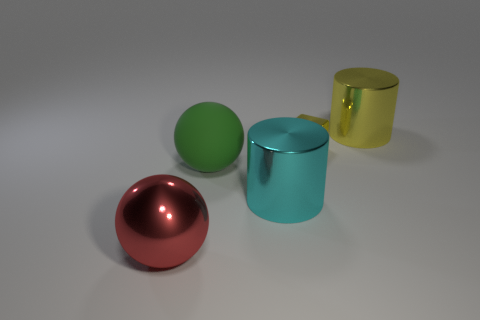What materials do the objects in the image appear to be made of? The objects in the image have a reflective surface that suggests they could be made of metal or a polished stone, each having a distinct, shiny appearance indicative of a carefully rendered texture.  Could you describe the lighting in the scene? The lighting in the scene is soft and diffuse, with the shadows indicating a light source above and to the right of the frame. This gentle illumination highlights the objects' contours and colors without creating harsh reflections. 